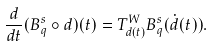Convert formula to latex. <formula><loc_0><loc_0><loc_500><loc_500>\frac { d } { d t } ( B ^ { s } _ { q } \circ d ) ( t ) = T ^ { W } _ { d ( t ) } B ^ { s } _ { q } ( \dot { d } ( t ) ) .</formula> 